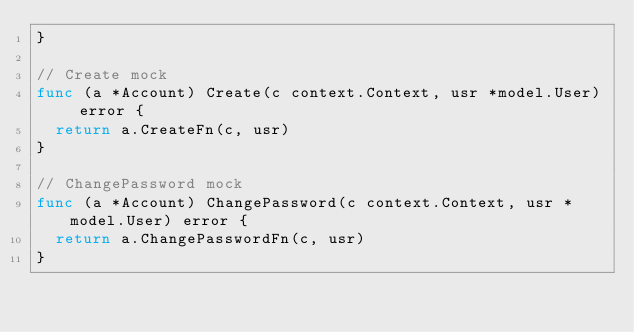<code> <loc_0><loc_0><loc_500><loc_500><_Go_>}

// Create mock
func (a *Account) Create(c context.Context, usr *model.User) error {
	return a.CreateFn(c, usr)
}

// ChangePassword mock
func (a *Account) ChangePassword(c context.Context, usr *model.User) error {
	return a.ChangePasswordFn(c, usr)
}
</code> 